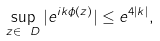Convert formula to latex. <formula><loc_0><loc_0><loc_500><loc_500>\sup _ { z \in \ D } | e ^ { i k \phi ( z ) } | \leq e ^ { 4 | k | } ,</formula> 